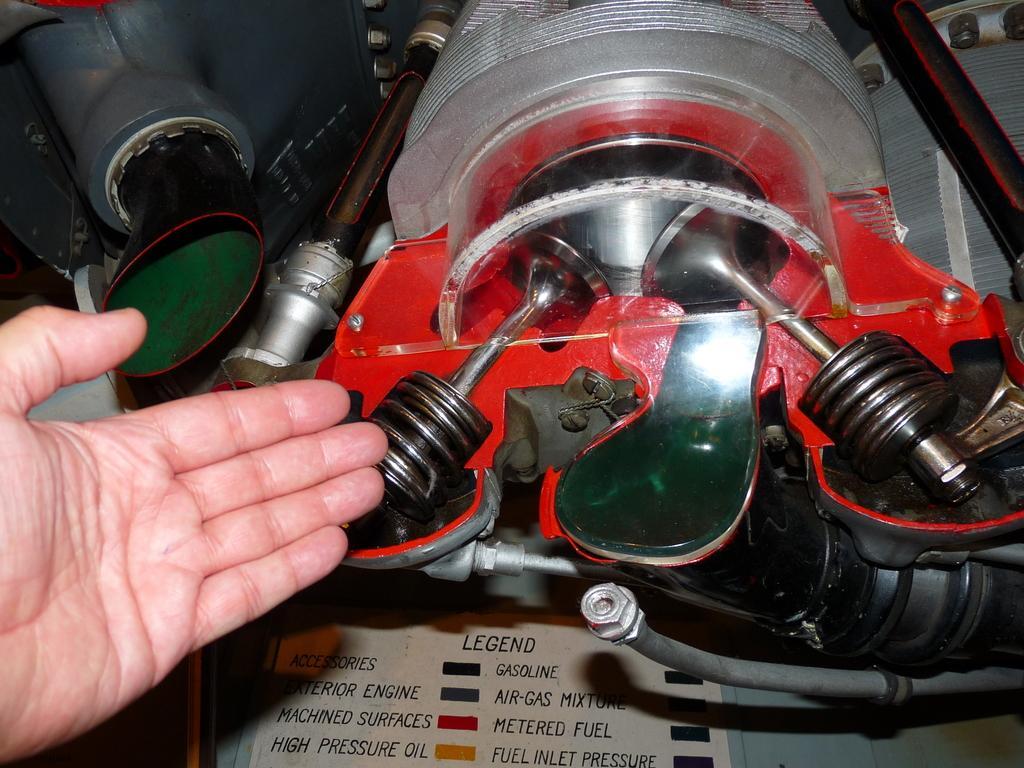How would you summarize this image in a sentence or two? In this image in the center there is an engine, and there is one persons hand. 